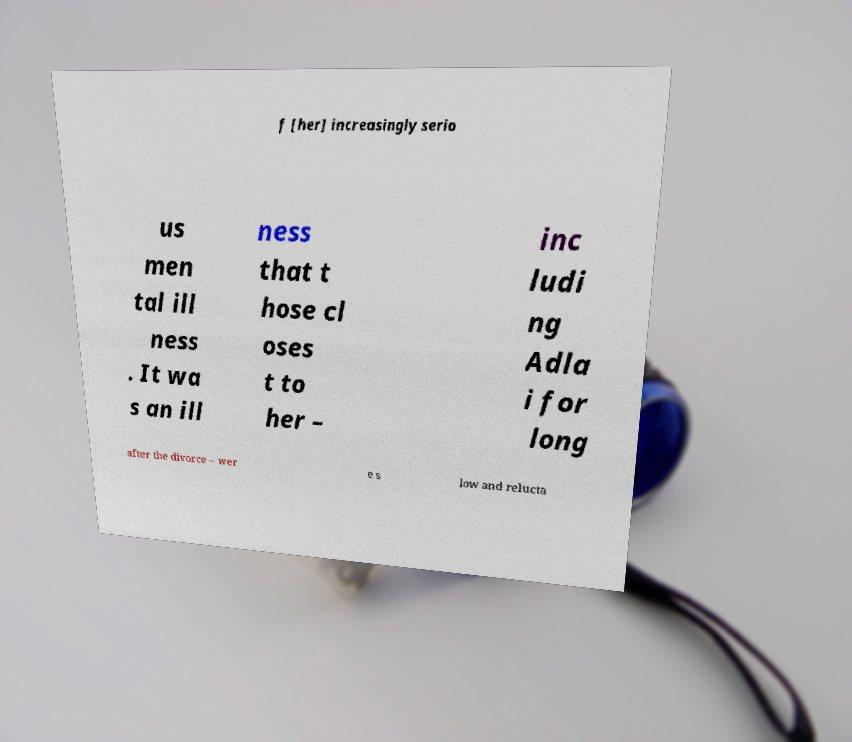What messages or text are displayed in this image? I need them in a readable, typed format. f [her] increasingly serio us men tal ill ness . It wa s an ill ness that t hose cl oses t to her – inc ludi ng Adla i for long after the divorce – wer e s low and relucta 